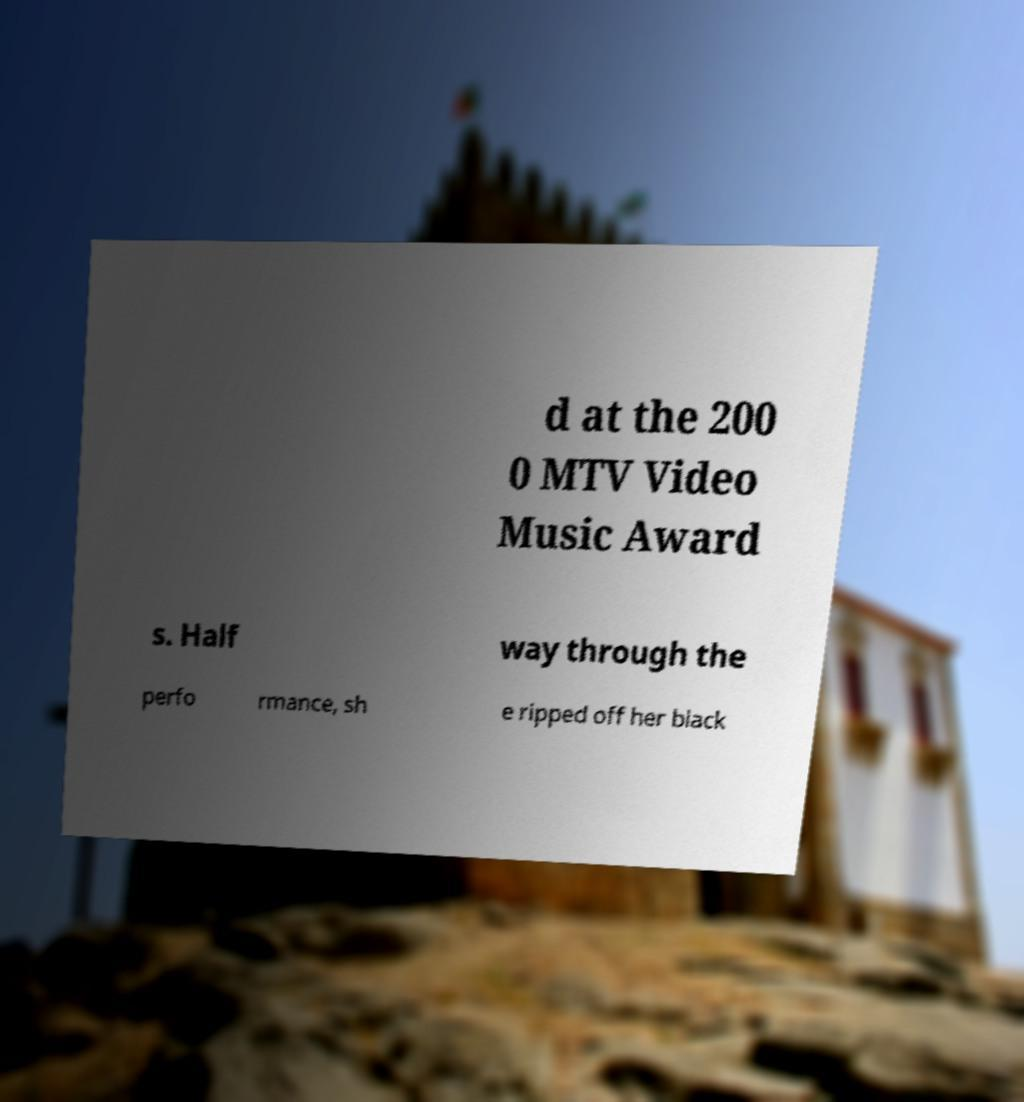What messages or text are displayed in this image? I need them in a readable, typed format. d at the 200 0 MTV Video Music Award s. Half way through the perfo rmance, sh e ripped off her black 